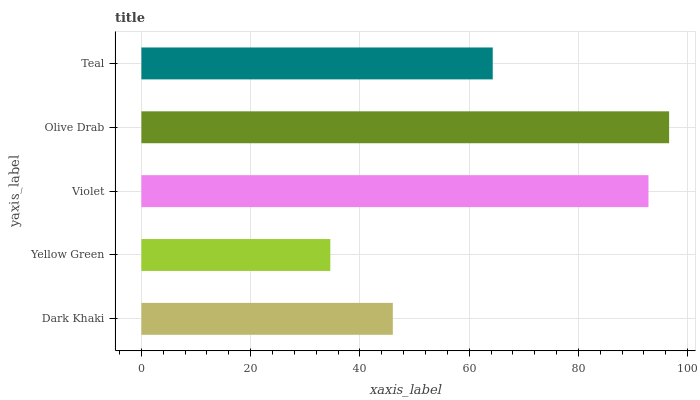Is Yellow Green the minimum?
Answer yes or no. Yes. Is Olive Drab the maximum?
Answer yes or no. Yes. Is Violet the minimum?
Answer yes or no. No. Is Violet the maximum?
Answer yes or no. No. Is Violet greater than Yellow Green?
Answer yes or no. Yes. Is Yellow Green less than Violet?
Answer yes or no. Yes. Is Yellow Green greater than Violet?
Answer yes or no. No. Is Violet less than Yellow Green?
Answer yes or no. No. Is Teal the high median?
Answer yes or no. Yes. Is Teal the low median?
Answer yes or no. Yes. Is Olive Drab the high median?
Answer yes or no. No. Is Dark Khaki the low median?
Answer yes or no. No. 